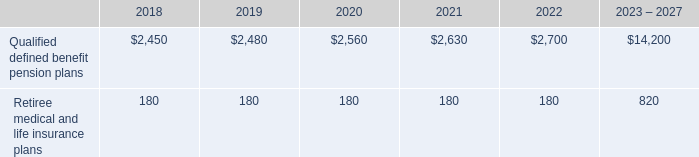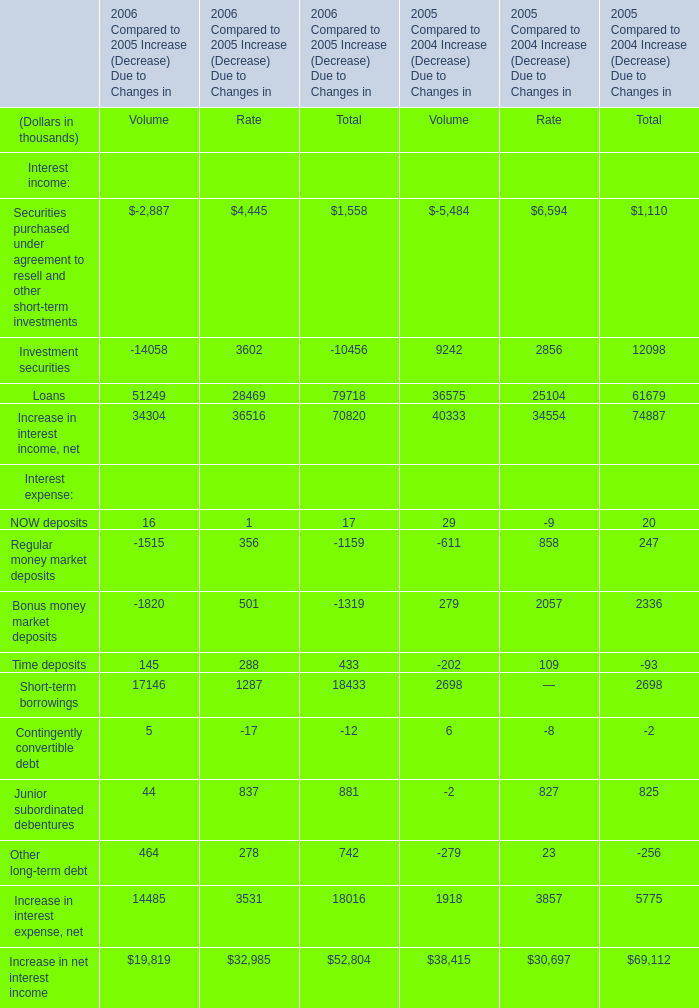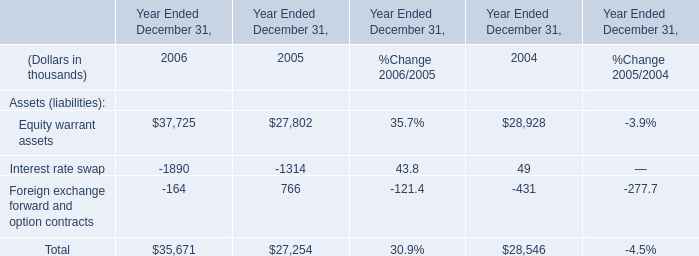What is the 2005 Compared to 2004 Increase (Decrease) Due to Changes in Volume for Loans? (in thousand) 
Answer: 36575. 